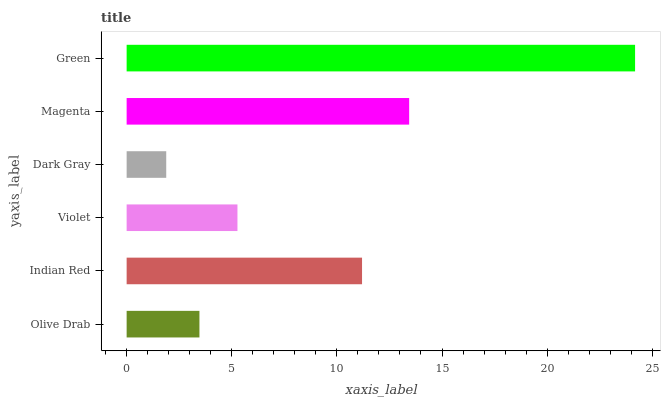Is Dark Gray the minimum?
Answer yes or no. Yes. Is Green the maximum?
Answer yes or no. Yes. Is Indian Red the minimum?
Answer yes or no. No. Is Indian Red the maximum?
Answer yes or no. No. Is Indian Red greater than Olive Drab?
Answer yes or no. Yes. Is Olive Drab less than Indian Red?
Answer yes or no. Yes. Is Olive Drab greater than Indian Red?
Answer yes or no. No. Is Indian Red less than Olive Drab?
Answer yes or no. No. Is Indian Red the high median?
Answer yes or no. Yes. Is Violet the low median?
Answer yes or no. Yes. Is Magenta the high median?
Answer yes or no. No. Is Magenta the low median?
Answer yes or no. No. 